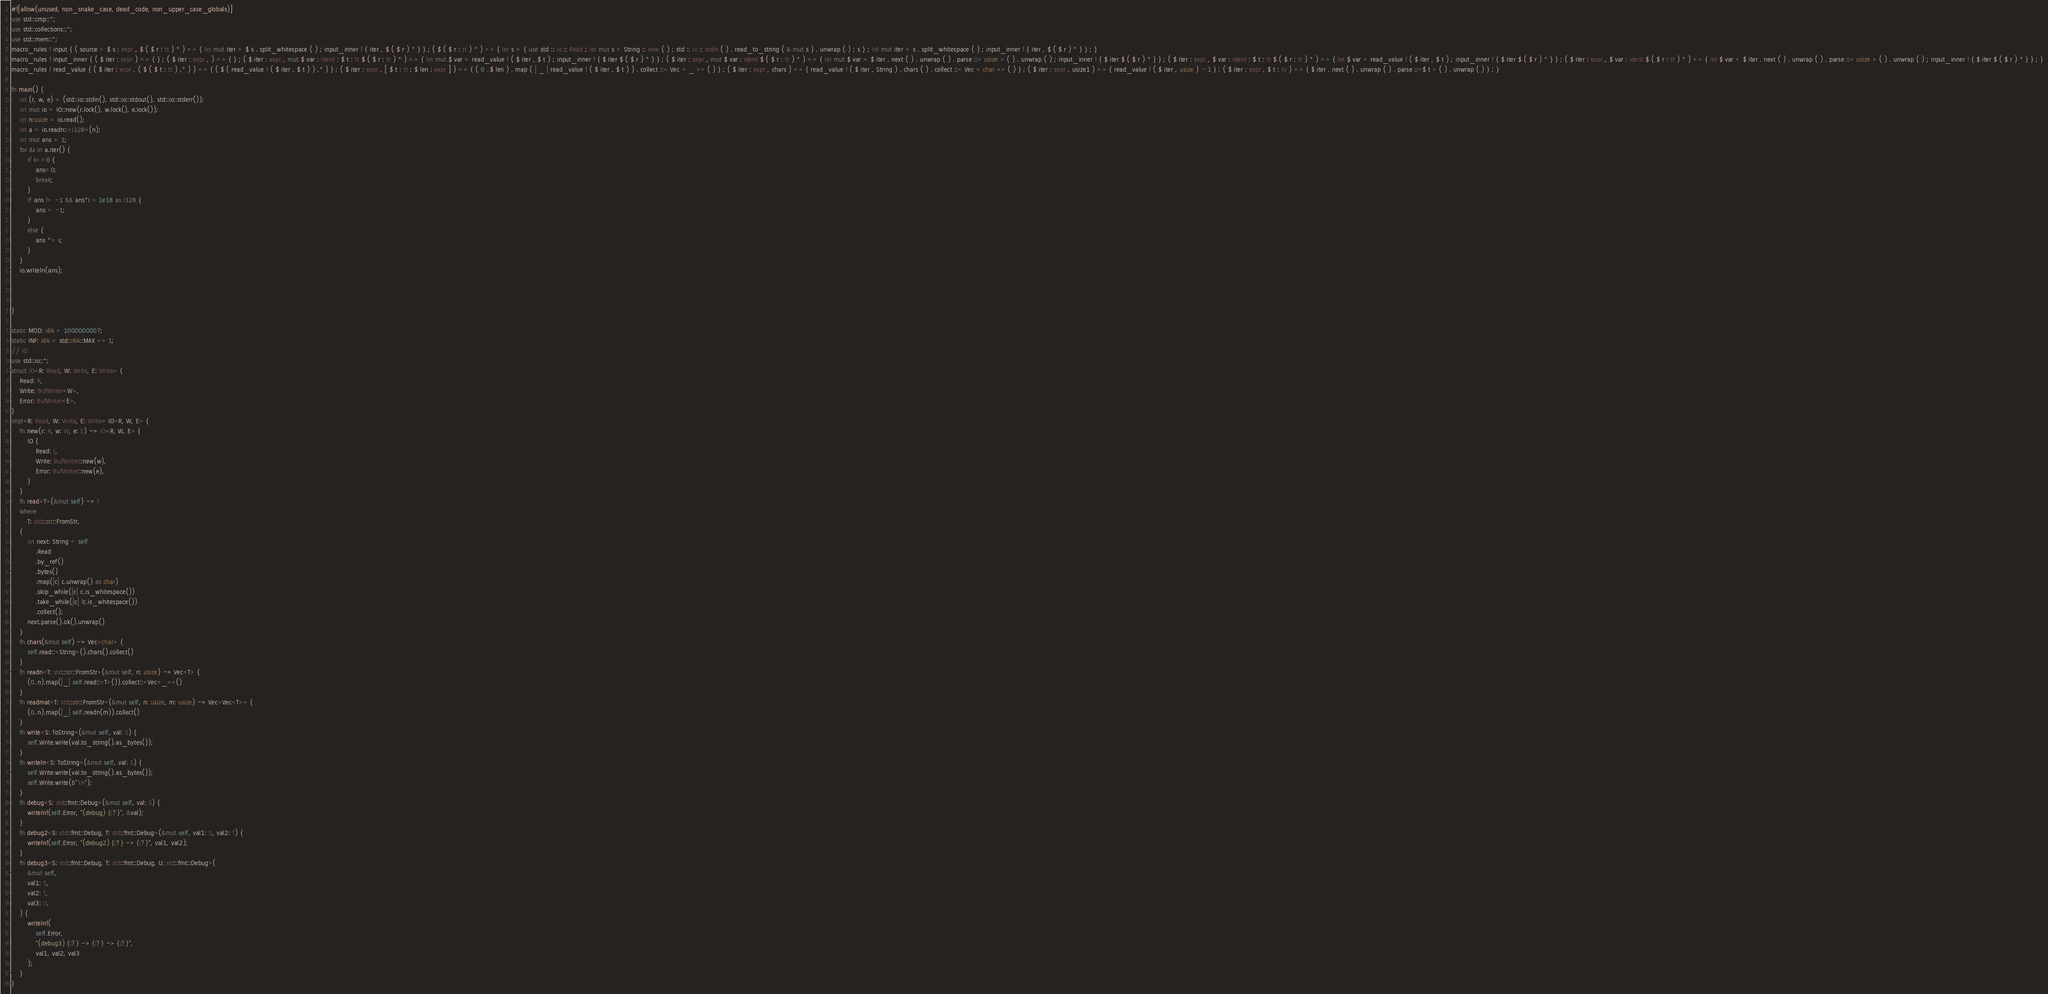<code> <loc_0><loc_0><loc_500><loc_500><_Rust_>#![allow(unused, non_snake_case, dead_code, non_upper_case_globals)]
use std::cmp::*;
use std::collections::*;
use std::mem::*;
macro_rules ! input { ( source = $ s : expr , $ ( $ r : tt ) * ) => { let mut iter = $ s . split_whitespace ( ) ; input_inner ! { iter , $ ( $ r ) * } } ; ( $ ( $ r : tt ) * ) => { let s = { use std :: io :: Read ; let mut s = String :: new ( ) ; std :: io :: stdin ( ) . read_to_string ( & mut s ) . unwrap ( ) ; s } ; let mut iter = s . split_whitespace ( ) ; input_inner ! { iter , $ ( $ r ) * } } ; }
macro_rules ! input_inner { ( $ iter : expr ) => { } ; ( $ iter : expr , ) => { } ; ( $ iter : expr , mut $ var : ident : $ t : tt $ ( $ r : tt ) * ) => { let mut $ var = read_value ! ( $ iter , $ t ) ; input_inner ! { $ iter $ ( $ r ) * } } ; ( $ iter : expr , mut $ var : ident $ ( $ r : tt ) * ) => { let mut $ var = $ iter . next ( ) . unwrap ( ) . parse ::< usize > ( ) . unwrap ( ) ; input_inner ! { $ iter $ ( $ r ) * } } ; ( $ iter : expr , $ var : ident : $ t : tt $ ( $ r : tt ) * ) => { let $ var = read_value ! ( $ iter , $ t ) ; input_inner ! { $ iter $ ( $ r ) * } } ; ( $ iter : expr , $ var : ident $ ( $ r : tt ) * ) => { let $ var = $ iter . next ( ) . unwrap ( ) . parse ::< usize > ( ) . unwrap ( ) ; input_inner ! { $ iter $ ( $ r ) * } } ; }
macro_rules ! read_value { ( $ iter : expr , ( $ ( $ t : tt ) ,* ) ) => { ( $ ( read_value ! ( $ iter , $ t ) ) ,* ) } ; ( $ iter : expr , [ $ t : tt ; $ len : expr ] ) => { ( 0 ..$ len ) . map ( | _ | read_value ! ( $ iter , $ t ) ) . collect ::< Vec < _ >> ( ) } ; ( $ iter : expr , chars ) => { read_value ! ( $ iter , String ) . chars ( ) . collect ::< Vec < char >> ( ) } ; ( $ iter : expr , usize1 ) => { read_value ! ( $ iter , usize ) - 1 } ; ( $ iter : expr , $ t : ty ) => { $ iter . next ( ) . unwrap ( ) . parse ::<$ t > ( ) . unwrap ( ) } ; }

fn main() {
    let (r, w, e) = (std::io::stdin(), std::io::stdout(), std::io::stderr());
    let mut io = IO::new(r.lock(), w.lock(), e.lock());
    let n:usize = io.read();
    let a = io.readn::<i128>(n);
    let mut ans = 1;
    for &i in a.iter() {
        if i==0 {
            ans=0;
            break;
        }
        if ans != -1 && ans*i > 1e18 as i128 {
            ans = -1;
        }
        else {
            ans *= i;
        }
    }
    io.writeln(ans);



}

static MOD: i64 = 1000000007;
static INF: i64 = std::i64::MAX >> 1;
// IO
use std::io::*;
struct IO<R: Read, W: Write, E: Write> {
    Read: R,
    Write: BufWriter<W>,
    Error: BufWriter<E>,
}
impl<R: Read, W: Write, E: Write> IO<R, W, E> {
    fn new(r: R, w: W, e: E) -> IO<R, W, E> {
        IO {
            Read: r,
            Write: BufWriter::new(w),
            Error: BufWriter::new(e),
        }
    }
    fn read<T>(&mut self) -> T
    where
        T: std::str::FromStr,
    {
        let next: String = self
            .Read
            .by_ref()
            .bytes()
            .map(|c| c.unwrap() as char)
            .skip_while(|c| c.is_whitespace())
            .take_while(|c| !c.is_whitespace())
            .collect();
        next.parse().ok().unwrap()
    }
    fn chars(&mut self) -> Vec<char> {
        self.read::<String>().chars().collect()
    }
    fn readn<T: std::str::FromStr>(&mut self, n: usize) -> Vec<T> {
        (0..n).map(|_| self.read::<T>()).collect::<Vec<_>>()
    }
    fn readmat<T: std::str::FromStr>(&mut self, n: usize, m: usize) -> Vec<Vec<T>> {
        (0..n).map(|_| self.readn(m)).collect()
    }
    fn write<S: ToString>(&mut self, val: S) {
        self.Write.write(val.to_string().as_bytes());
    }
    fn writeln<S: ToString>(&mut self, val: S) {
        self.Write.write(val.to_string().as_bytes());
        self.Write.write(b"\n");
    }
    fn debug<S: std::fmt::Debug>(&mut self, val: S) {
        writeln!(self.Error, "(debug) {:?}", &val);
    }
    fn debug2<S: std::fmt::Debug, T: std::fmt::Debug>(&mut self, val1: S, val2: T) {
        writeln!(self.Error, "(debug2) {:?} -> {:?}", val1, val2);
    }
    fn debug3<S: std::fmt::Debug, T: std::fmt::Debug, U: std::fmt::Debug>(
        &mut self,
        val1: S,
        val2: T,
        val3: U,
    ) {
        writeln!(
            self.Error,
            "(debug3) {:?} -> {:?} -> {:?}",
            val1, val2, val3
        );
    }
}
</code> 